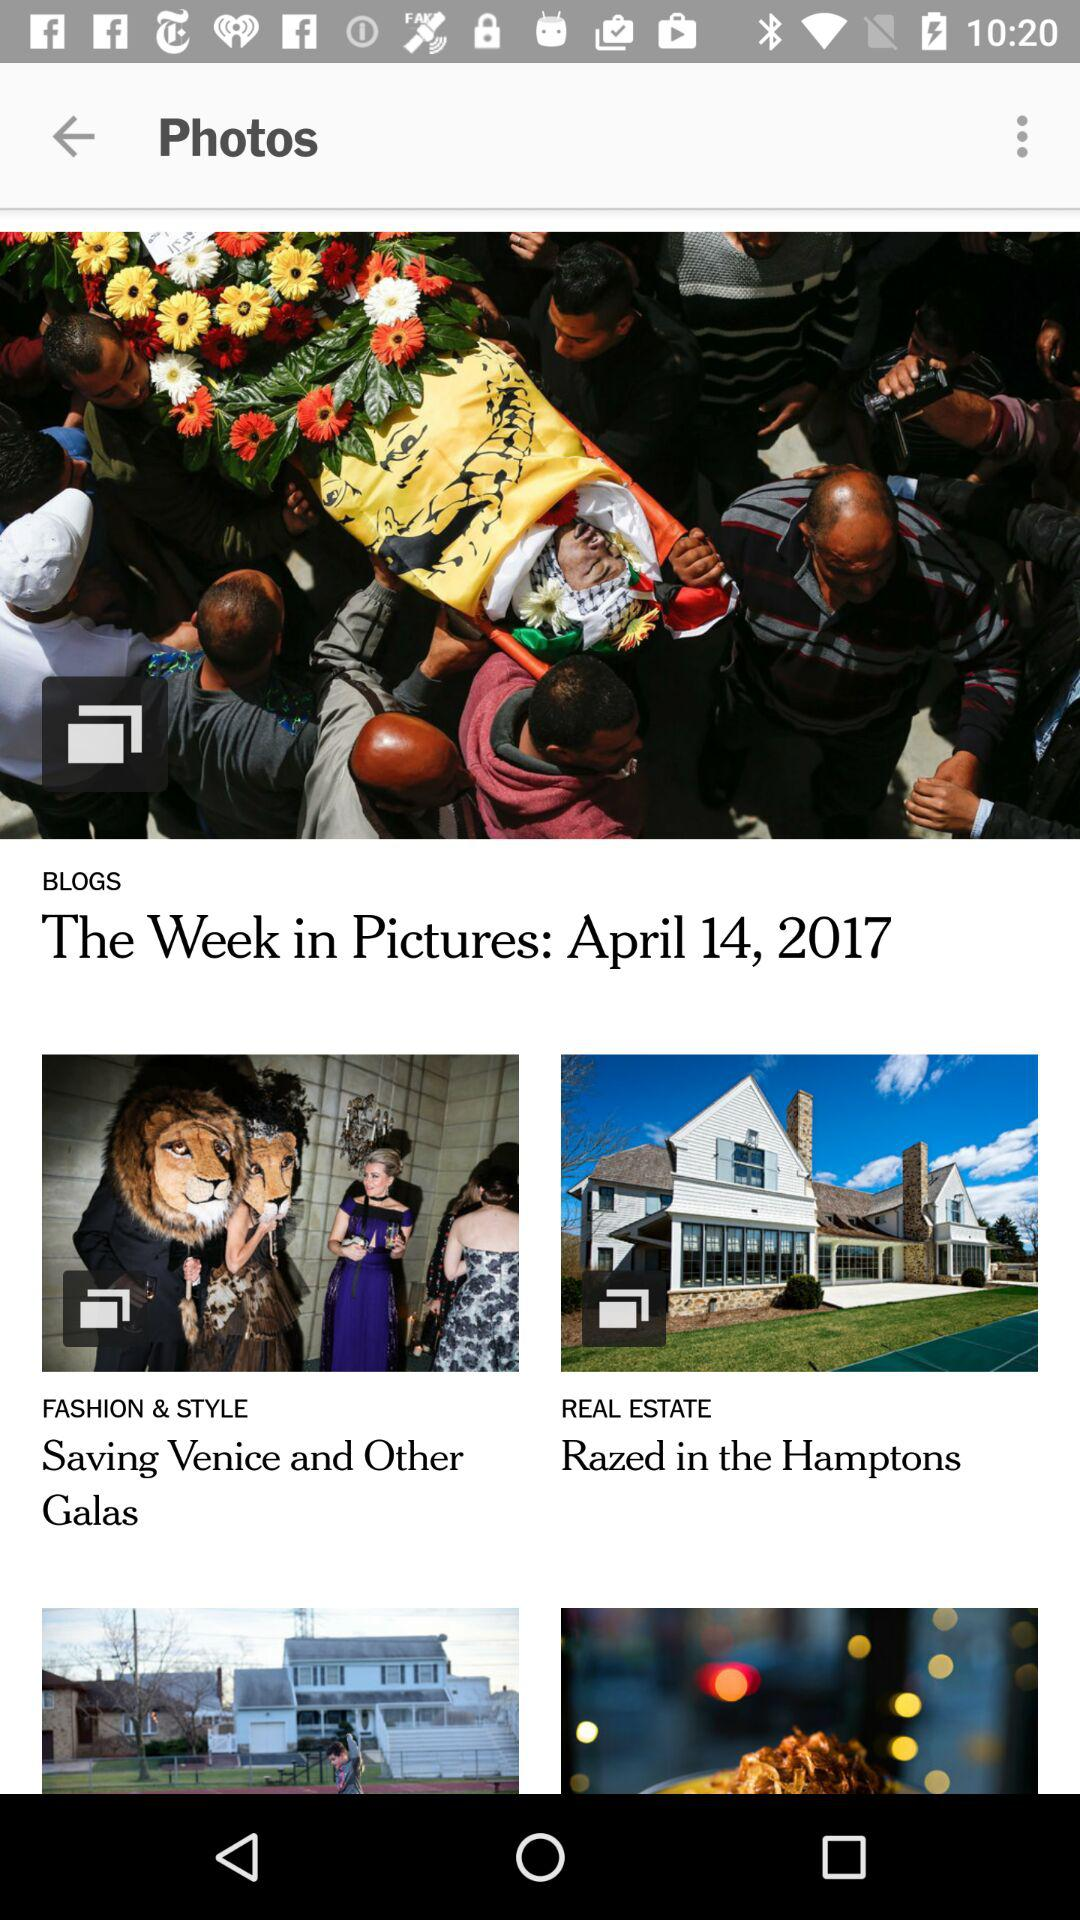What is the name of the blog which comes under the category of "REAL ESTATE"? The name of the blog is "Razed in the Hamptons". 